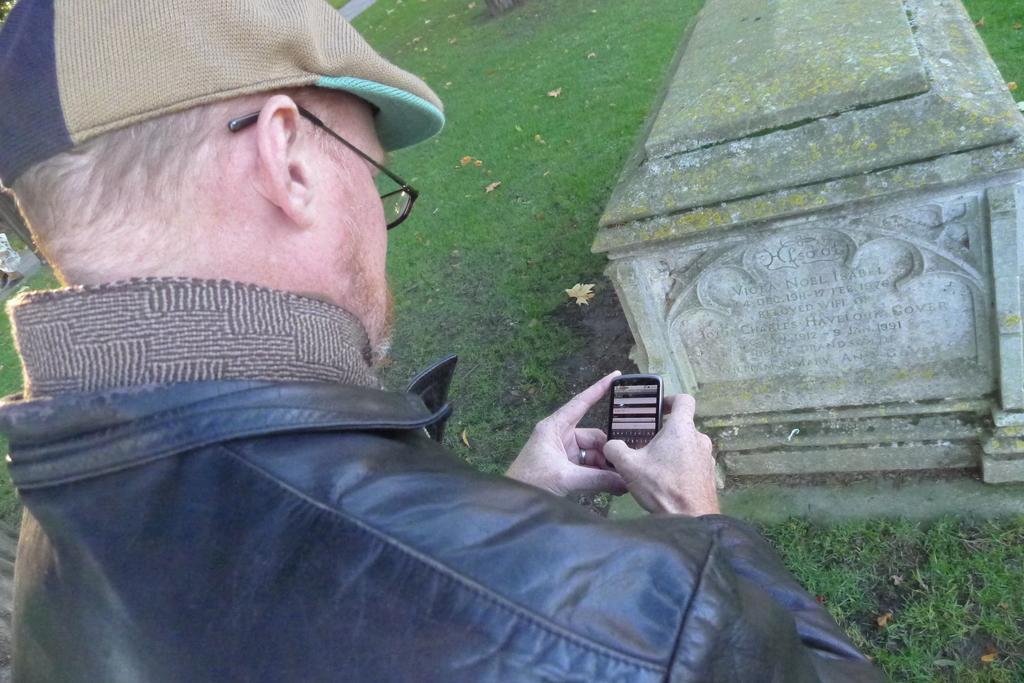Describe this image in one or two sentences. This picture shows a man standing and holding a mobile in his hand and we see a gravestone and grass 